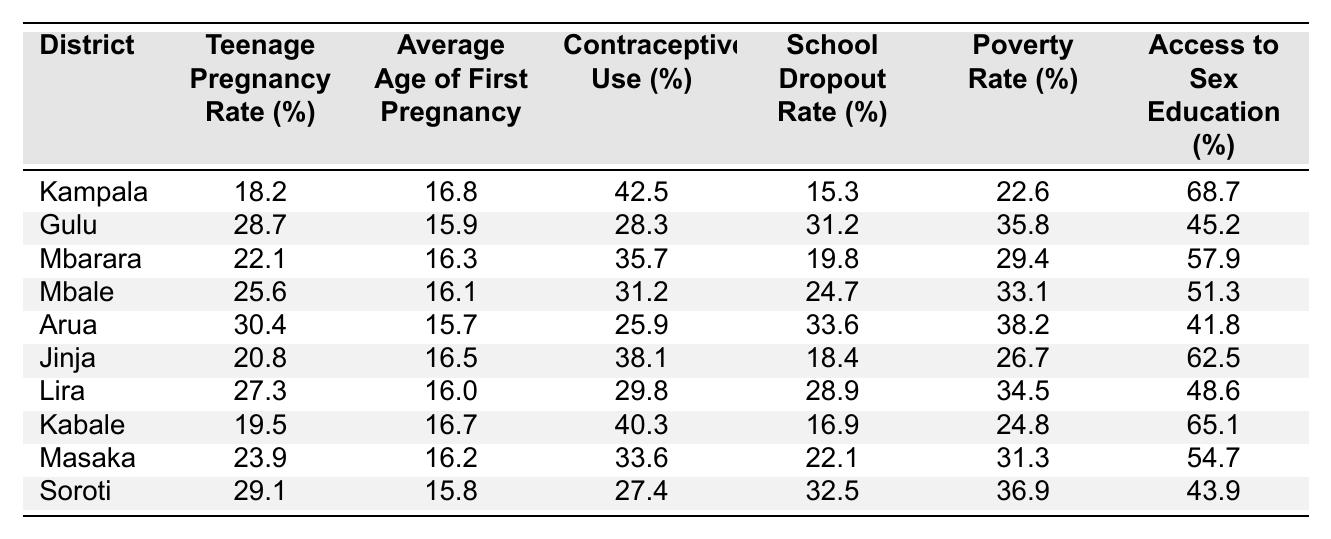What is the teenage pregnancy rate in Kampala? The table lists Kampala's teenage pregnancy rate as 18.2%.
Answer: 18.2% Which district has the highest average age of first pregnancy? By looking at the table, Arua has the highest average age of first pregnancy at 15.7 years.
Answer: Arua What percentage of contraceptive use is reported in Gulu? The table indicates that contraceptive use in Gulu is 28.3%.
Answer: 28.3% What is the average age of first pregnancy across all districts? To find the average, we add the average ages for all districts: (16.8 + 15.9 + 16.3 + 16.1 + 15.7 + 16.5 + 16.0 + 16.7 + 16.2 + 15.8) = 164.9, then divide by 10 districts to get 16.49.
Answer: 16.49 Is the school dropout rate higher in Arua or Jinja? Checking the table, Arua has a school dropout rate of 33.6%, while Jinja has 18.4%. Therefore, Arua has a higher dropout rate.
Answer: Yes, Arua has a higher dropout rate Which district has the lowest access to sex education? The lowest access to sex education is found in Arua at 41.8%.
Answer: Arua What is the difference in teenage pregnancy rates between Gulu and Kampala? Gulu's rate is 28.7%, while Kampala's is 18.2%. The difference is calculated as 28.7 - 18.2 = 10.5%.
Answer: 10.5% Which district has the highest poverty rate? According to the table, Arua has the highest poverty rate at 38.2%.
Answer: Arua Does higher contraceptive use correlate to lower teenage pregnancy rates in the table? By comparing values, Gulu has low contraceptive use (28.3%) and a high teenage pregnancy rate (28.7%), while Kampala has higher contraceptive use (42.5%) and a lower rate (18.2%). It suggests a correlation, but further analysis is needed for a strong conclusion.
Answer: Yes, preliminary observation suggests a correlation What is the average teenage pregnancy rate for districts with access to sex education above 60%? The districts with above 60% access to sex education are Kampala (68.7%) and Kabale (65.1%). Their average is (18.2 + 19.5)/2 = 18.85%.
Answer: 18.85% 